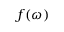Convert formula to latex. <formula><loc_0><loc_0><loc_500><loc_500>f ( \omega )</formula> 